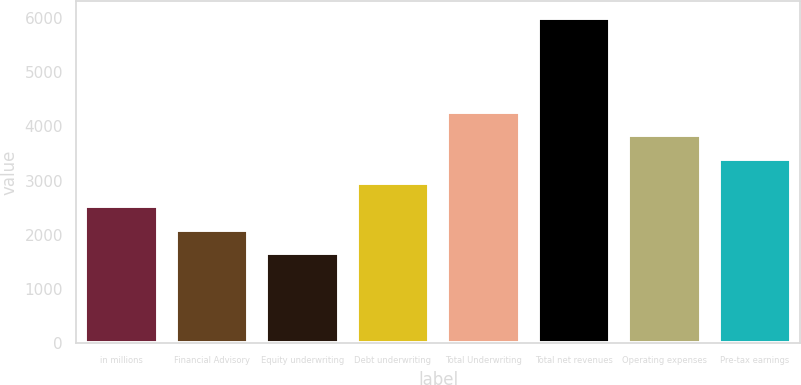<chart> <loc_0><loc_0><loc_500><loc_500><bar_chart><fcel>in millions<fcel>Financial Advisory<fcel>Equity underwriting<fcel>Debt underwriting<fcel>Total Underwriting<fcel>Total net revenues<fcel>Operating expenses<fcel>Pre-tax earnings<nl><fcel>2528<fcel>2093.5<fcel>1659<fcel>2962.5<fcel>4266<fcel>6004<fcel>3831.5<fcel>3397<nl></chart> 